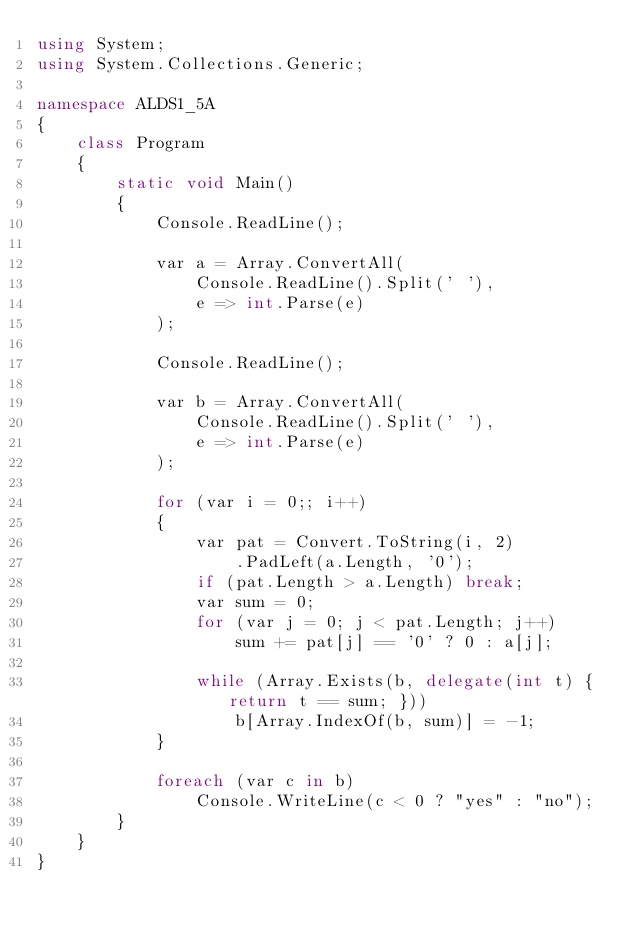Convert code to text. <code><loc_0><loc_0><loc_500><loc_500><_C#_>using System;
using System.Collections.Generic;

namespace ALDS1_5A
{
    class Program
    {
        static void Main()
        {
            Console.ReadLine();

            var a = Array.ConvertAll(
                Console.ReadLine().Split(' '),
                e => int.Parse(e)
            );

            Console.ReadLine();

            var b = Array.ConvertAll(
                Console.ReadLine().Split(' '),
                e => int.Parse(e)
            );

            for (var i = 0;; i++)
            {
                var pat = Convert.ToString(i, 2)
                    .PadLeft(a.Length, '0');
                if (pat.Length > a.Length) break;
                var sum = 0;
                for (var j = 0; j < pat.Length; j++)
                    sum += pat[j] == '0' ? 0 : a[j];
                
                while (Array.Exists(b, delegate(int t) { return t == sum; }))
                    b[Array.IndexOf(b, sum)] = -1;
            }

            foreach (var c in b)
                Console.WriteLine(c < 0 ? "yes" : "no");
        }
    }
}
</code> 